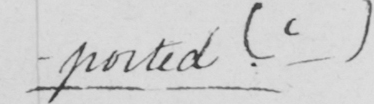What does this handwritten line say? -ported .  ( c ) 